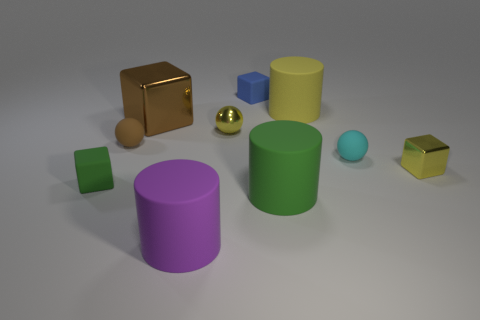What is the size of the blue thing?
Your response must be concise. Small. There is a metallic ball that is the same size as the yellow cube; what is its color?
Make the answer very short. Yellow. Is there a tiny rubber sphere of the same color as the small shiny ball?
Your response must be concise. No. What is the small yellow ball made of?
Provide a succinct answer. Metal. How many blue objects are there?
Offer a terse response. 1. Is the color of the small sphere left of the yellow metal sphere the same as the small sphere that is on the right side of the tiny blue cube?
Your answer should be very brief. No. There is a block that is the same color as the metal sphere; what is its size?
Provide a succinct answer. Small. What number of other objects are there of the same size as the yellow metallic sphere?
Your response must be concise. 5. What is the color of the big matte thing behind the big green rubber thing?
Offer a very short reply. Yellow. Is the material of the green object on the left side of the brown shiny object the same as the small yellow block?
Give a very brief answer. No. 